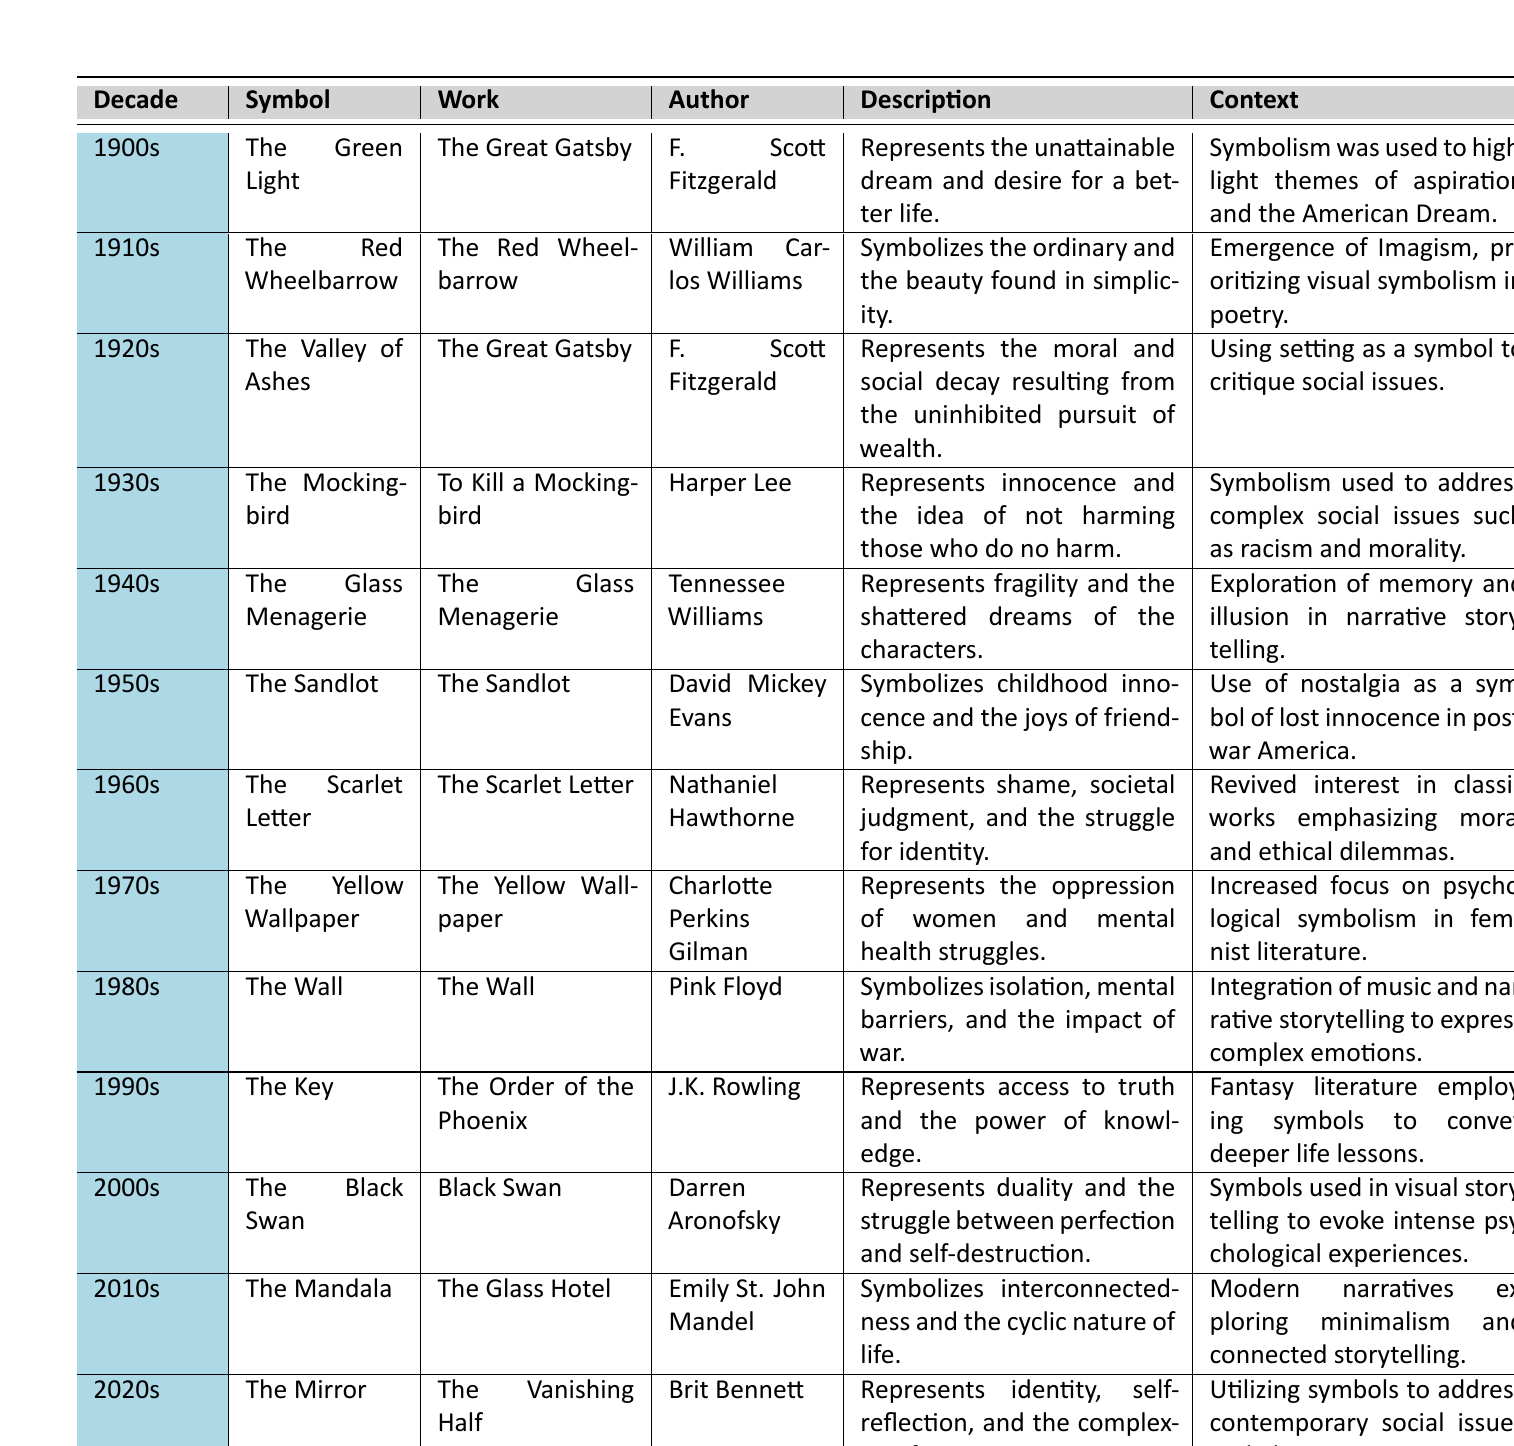What symbol from the 1960s represents shame and societal judgment? Referring to the table, the symbol from the 1960s is "The Scarlet Letter," which is specifically mentioned in the context of representing shame and societal judgment.
Answer: The Scarlet Letter Which author wrote "The Mockingbird"? Looking at the table, "The Mockingbird" is authored by Harper Lee, as stated directly in the corresponding row for the 1930s.
Answer: Harper Lee In which decade was the symbol "The Yellow Wallpaper" introduced? The table specifies that "The Yellow Wallpaper" was introduced in the 1970s, as listed in that decade's row.
Answer: 1970s What is the main theme represented by "The Glass Menagerie"? The description in the table for "The Glass Menagerie" indicates that it represents fragility and shattered dreams, reflecting the main theme of the narrative.
Answer: Fragility and shattered dreams How many symbols represent societal issues from the 1930s to the 1970s? The table lists "The Mockingbird" (1930s), "The Scarlet Letter" (1960s), and "The Yellow Wallpaper" (1970s) as symbols that address societal issues. This results in a count of 3 symbols.
Answer: 3 Does "The Valley of Ashes" relate to wealth? Yes, according to the description under "The Valley of Ashes," it represents the moral and social decay resulting from the pursuit of wealth, confirming its relation to that theme.
Answer: Yes Which symbol's description emphasizes interconnectedness and cyclic nature? The symbol "The Mandala," found in the 2010s section of the table, emphasizes interconnectedness and the cyclic nature of life as per its description.
Answer: The Mandala Compare the contexts of symbols in the 2000s and 2010s. What do they focus on? The context for the 2000s discusses symbols used in visual storytelling to evoke psychological experiences, while the 2010s context notes modern narratives exploring minimalism and connected storytelling. This shows a shift from psychological focus to more conceptual and narrative connections.
Answer: Psychological experiences vs. minimalism and connected storytelling Which decade features a symbol representing duality and the struggle between perfection and self-destruction? Referring to the table, this description matches "The Black Swan," which is found in the 2000s.
Answer: 2000s What does the symbol "The Key" signify in the 1990s? The description for "The Key" states it represents access to truth and the power of knowledge, explaining its significance within the 1990s section of the table.
Answer: Access to truth and power of knowledge How has the representation of societal issues evolved from the 1900s to the 2020s? In the 1900s, symbolism highlighted themes of aspiration and the American Dream; by the 2020s, it addresses contemporary issues like identity and race, indicating a progression toward complex social narratives reflecting deeper societal problems.
Answer: Evolved from aspiration to complex social issues 